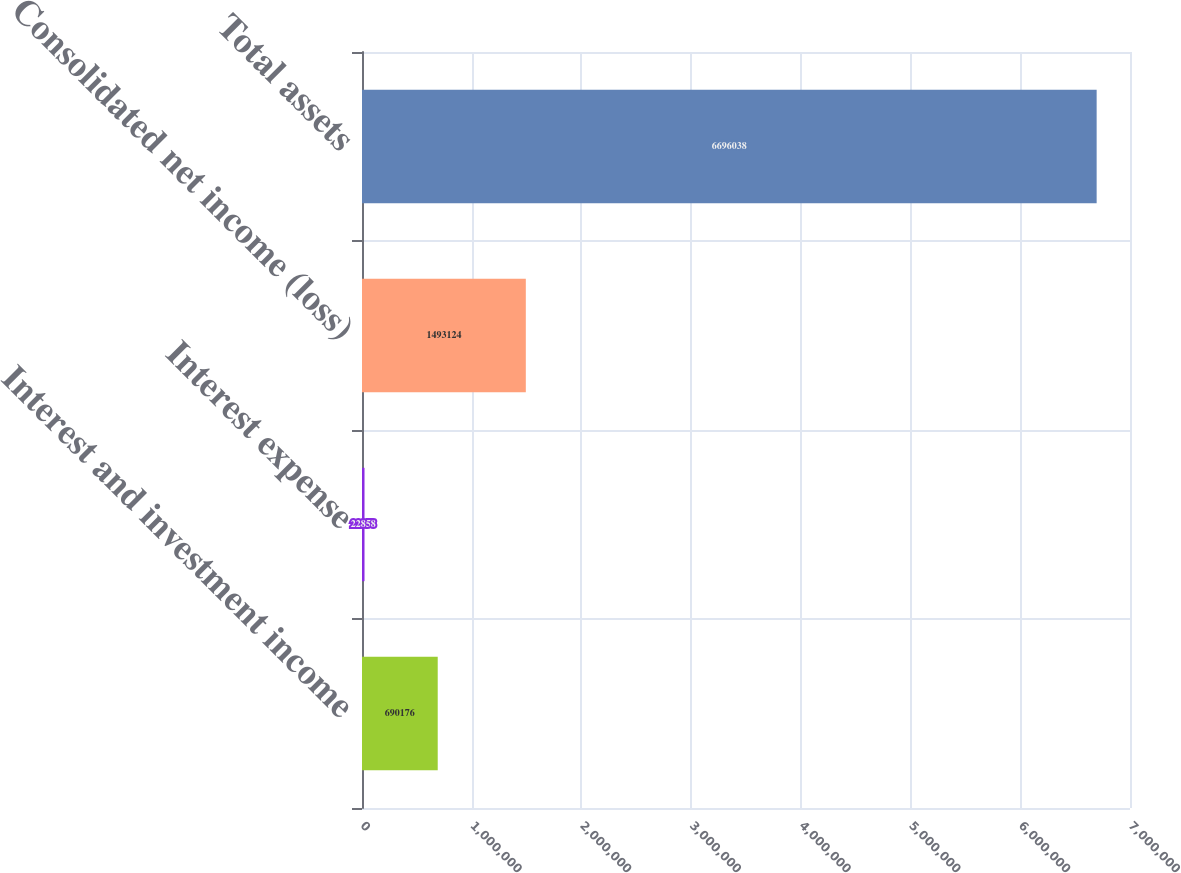<chart> <loc_0><loc_0><loc_500><loc_500><bar_chart><fcel>Interest and investment income<fcel>Interest expense<fcel>Consolidated net income (loss)<fcel>Total assets<nl><fcel>690176<fcel>22858<fcel>1.49312e+06<fcel>6.69604e+06<nl></chart> 